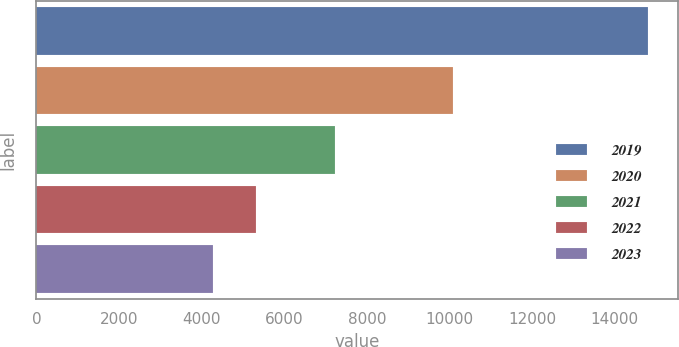Convert chart to OTSL. <chart><loc_0><loc_0><loc_500><loc_500><bar_chart><fcel>2019<fcel>2020<fcel>2021<fcel>2022<fcel>2023<nl><fcel>14808<fcel>10081<fcel>7218<fcel>5318.4<fcel>4264<nl></chart> 